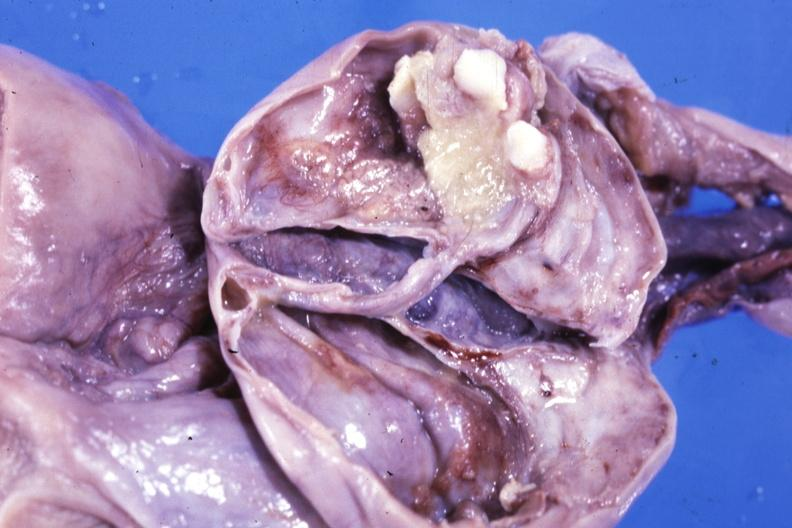s endometritis present?
Answer the question using a single word or phrase. No 